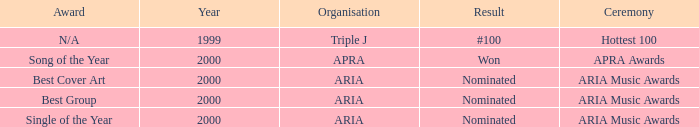Which award was nominated for in 2000? Best Cover Art, Best Group, Single of the Year. 